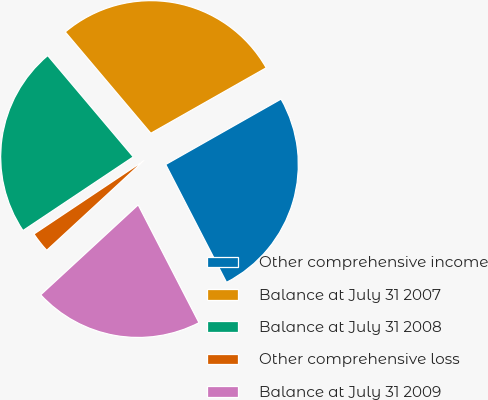Convert chart to OTSL. <chart><loc_0><loc_0><loc_500><loc_500><pie_chart><fcel>Other comprehensive income<fcel>Balance at July 31 2007<fcel>Balance at July 31 2008<fcel>Other comprehensive loss<fcel>Balance at July 31 2009<nl><fcel>25.63%<fcel>27.95%<fcel>23.21%<fcel>2.49%<fcel>20.72%<nl></chart> 